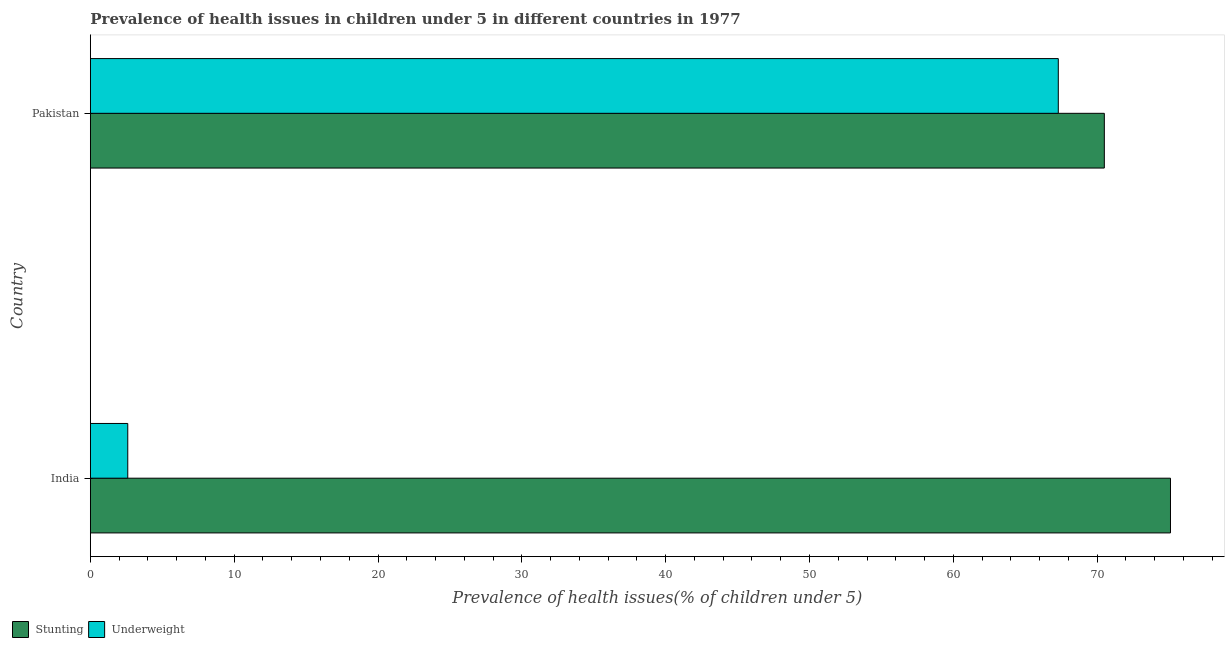How many groups of bars are there?
Ensure brevity in your answer.  2. Are the number of bars per tick equal to the number of legend labels?
Your response must be concise. Yes. How many bars are there on the 1st tick from the top?
Give a very brief answer. 2. How many bars are there on the 1st tick from the bottom?
Your answer should be compact. 2. What is the label of the 2nd group of bars from the top?
Give a very brief answer. India. In how many cases, is the number of bars for a given country not equal to the number of legend labels?
Ensure brevity in your answer.  0. What is the percentage of underweight children in India?
Keep it short and to the point. 2.6. Across all countries, what is the maximum percentage of stunted children?
Make the answer very short. 75.1. Across all countries, what is the minimum percentage of stunted children?
Give a very brief answer. 70.5. What is the total percentage of underweight children in the graph?
Keep it short and to the point. 69.9. What is the difference between the percentage of underweight children in India and that in Pakistan?
Provide a succinct answer. -64.7. What is the difference between the percentage of underweight children in Pakistan and the percentage of stunted children in India?
Give a very brief answer. -7.8. What is the average percentage of underweight children per country?
Offer a terse response. 34.95. What is the difference between the percentage of underweight children and percentage of stunted children in India?
Your answer should be very brief. -72.5. What is the ratio of the percentage of underweight children in India to that in Pakistan?
Offer a terse response. 0.04. Is the percentage of stunted children in India less than that in Pakistan?
Your answer should be very brief. No. In how many countries, is the percentage of stunted children greater than the average percentage of stunted children taken over all countries?
Provide a succinct answer. 1. What does the 2nd bar from the top in India represents?
Make the answer very short. Stunting. What does the 2nd bar from the bottom in India represents?
Provide a short and direct response. Underweight. How many bars are there?
Make the answer very short. 4. Are all the bars in the graph horizontal?
Keep it short and to the point. Yes. How many countries are there in the graph?
Ensure brevity in your answer.  2. What is the difference between two consecutive major ticks on the X-axis?
Provide a short and direct response. 10. Does the graph contain grids?
Ensure brevity in your answer.  No. Where does the legend appear in the graph?
Offer a very short reply. Bottom left. What is the title of the graph?
Provide a short and direct response. Prevalence of health issues in children under 5 in different countries in 1977. What is the label or title of the X-axis?
Your answer should be very brief. Prevalence of health issues(% of children under 5). What is the Prevalence of health issues(% of children under 5) in Stunting in India?
Make the answer very short. 75.1. What is the Prevalence of health issues(% of children under 5) in Underweight in India?
Provide a succinct answer. 2.6. What is the Prevalence of health issues(% of children under 5) of Stunting in Pakistan?
Make the answer very short. 70.5. What is the Prevalence of health issues(% of children under 5) of Underweight in Pakistan?
Offer a very short reply. 67.3. Across all countries, what is the maximum Prevalence of health issues(% of children under 5) in Stunting?
Provide a short and direct response. 75.1. Across all countries, what is the maximum Prevalence of health issues(% of children under 5) of Underweight?
Offer a very short reply. 67.3. Across all countries, what is the minimum Prevalence of health issues(% of children under 5) in Stunting?
Make the answer very short. 70.5. Across all countries, what is the minimum Prevalence of health issues(% of children under 5) of Underweight?
Provide a short and direct response. 2.6. What is the total Prevalence of health issues(% of children under 5) in Stunting in the graph?
Give a very brief answer. 145.6. What is the total Prevalence of health issues(% of children under 5) of Underweight in the graph?
Provide a short and direct response. 69.9. What is the difference between the Prevalence of health issues(% of children under 5) of Underweight in India and that in Pakistan?
Your answer should be very brief. -64.7. What is the average Prevalence of health issues(% of children under 5) of Stunting per country?
Give a very brief answer. 72.8. What is the average Prevalence of health issues(% of children under 5) in Underweight per country?
Your answer should be very brief. 34.95. What is the difference between the Prevalence of health issues(% of children under 5) of Stunting and Prevalence of health issues(% of children under 5) of Underweight in India?
Ensure brevity in your answer.  72.5. What is the ratio of the Prevalence of health issues(% of children under 5) of Stunting in India to that in Pakistan?
Offer a terse response. 1.07. What is the ratio of the Prevalence of health issues(% of children under 5) in Underweight in India to that in Pakistan?
Provide a succinct answer. 0.04. What is the difference between the highest and the second highest Prevalence of health issues(% of children under 5) of Underweight?
Your answer should be compact. 64.7. What is the difference between the highest and the lowest Prevalence of health issues(% of children under 5) of Underweight?
Your answer should be compact. 64.7. 